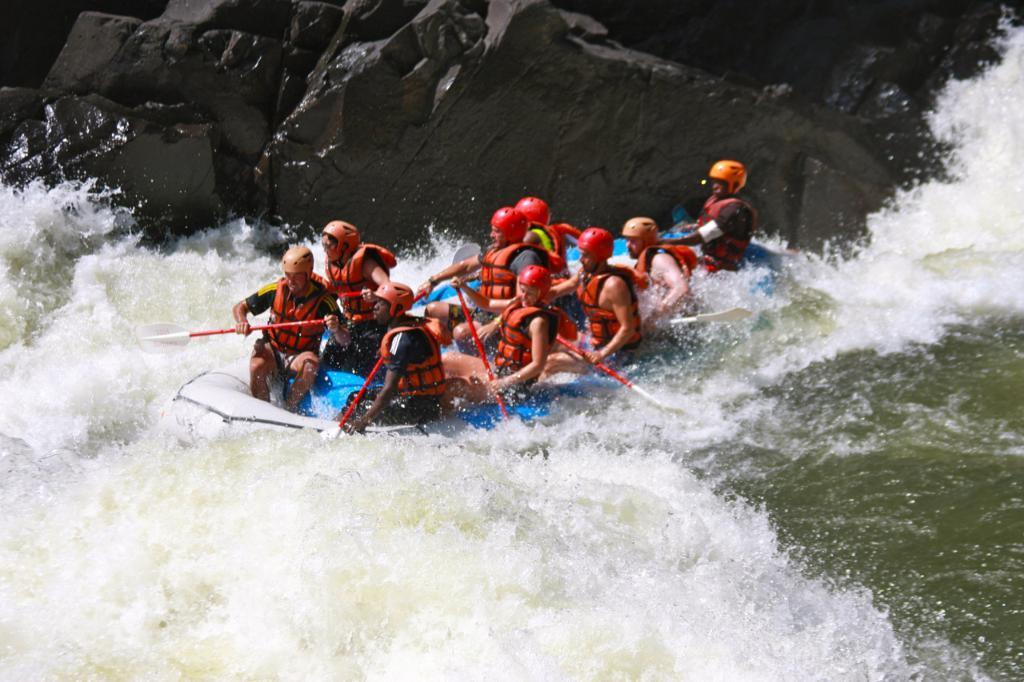Please provide a concise description of this image. In this picture we can see a group of people rafting in white water. At the top it is rock. 